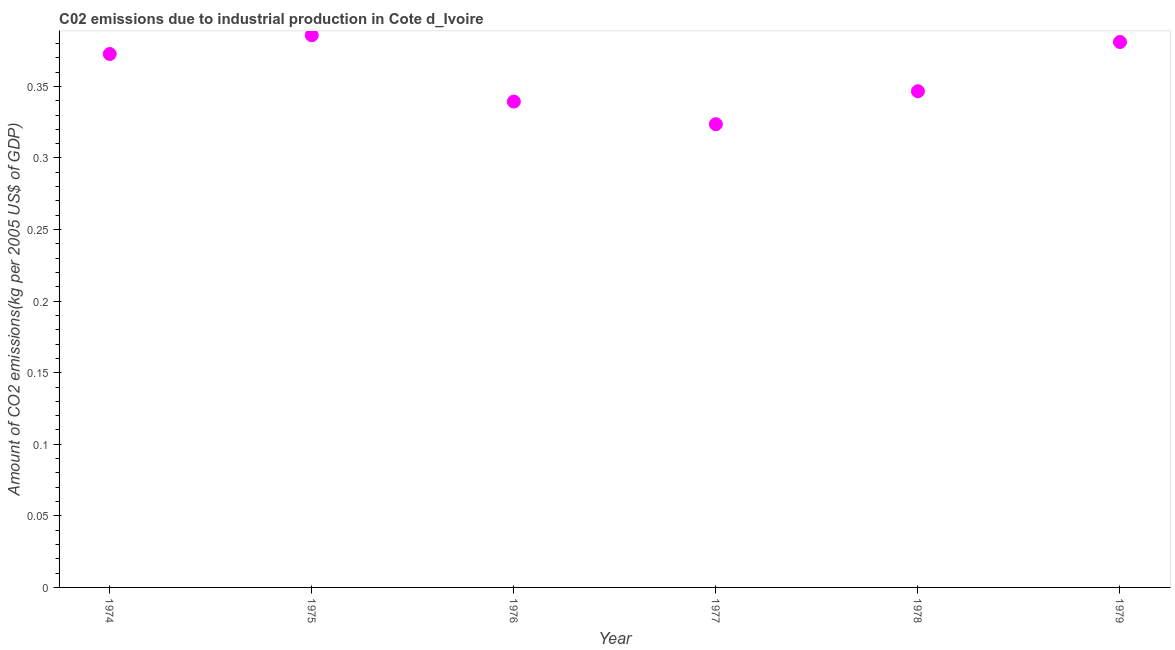What is the amount of co2 emissions in 1979?
Provide a succinct answer. 0.38. Across all years, what is the maximum amount of co2 emissions?
Keep it short and to the point. 0.39. Across all years, what is the minimum amount of co2 emissions?
Your answer should be compact. 0.32. In which year was the amount of co2 emissions maximum?
Give a very brief answer. 1975. What is the sum of the amount of co2 emissions?
Ensure brevity in your answer.  2.15. What is the difference between the amount of co2 emissions in 1976 and 1979?
Ensure brevity in your answer.  -0.04. What is the average amount of co2 emissions per year?
Offer a very short reply. 0.36. What is the median amount of co2 emissions?
Provide a short and direct response. 0.36. In how many years, is the amount of co2 emissions greater than 0.25 kg per 2005 US$ of GDP?
Offer a terse response. 6. What is the ratio of the amount of co2 emissions in 1978 to that in 1979?
Provide a succinct answer. 0.91. Is the amount of co2 emissions in 1976 less than that in 1978?
Provide a succinct answer. Yes. What is the difference between the highest and the second highest amount of co2 emissions?
Make the answer very short. 0. What is the difference between the highest and the lowest amount of co2 emissions?
Your response must be concise. 0.06. Does the amount of co2 emissions monotonically increase over the years?
Your answer should be compact. No. How many years are there in the graph?
Offer a terse response. 6. Are the values on the major ticks of Y-axis written in scientific E-notation?
Keep it short and to the point. No. Does the graph contain any zero values?
Provide a succinct answer. No. Does the graph contain grids?
Provide a succinct answer. No. What is the title of the graph?
Give a very brief answer. C02 emissions due to industrial production in Cote d_Ivoire. What is the label or title of the Y-axis?
Offer a terse response. Amount of CO2 emissions(kg per 2005 US$ of GDP). What is the Amount of CO2 emissions(kg per 2005 US$ of GDP) in 1974?
Offer a very short reply. 0.37. What is the Amount of CO2 emissions(kg per 2005 US$ of GDP) in 1975?
Offer a terse response. 0.39. What is the Amount of CO2 emissions(kg per 2005 US$ of GDP) in 1976?
Your answer should be very brief. 0.34. What is the Amount of CO2 emissions(kg per 2005 US$ of GDP) in 1977?
Your response must be concise. 0.32. What is the Amount of CO2 emissions(kg per 2005 US$ of GDP) in 1978?
Keep it short and to the point. 0.35. What is the Amount of CO2 emissions(kg per 2005 US$ of GDP) in 1979?
Provide a short and direct response. 0.38. What is the difference between the Amount of CO2 emissions(kg per 2005 US$ of GDP) in 1974 and 1975?
Your response must be concise. -0.01. What is the difference between the Amount of CO2 emissions(kg per 2005 US$ of GDP) in 1974 and 1976?
Make the answer very short. 0.03. What is the difference between the Amount of CO2 emissions(kg per 2005 US$ of GDP) in 1974 and 1977?
Ensure brevity in your answer.  0.05. What is the difference between the Amount of CO2 emissions(kg per 2005 US$ of GDP) in 1974 and 1978?
Give a very brief answer. 0.03. What is the difference between the Amount of CO2 emissions(kg per 2005 US$ of GDP) in 1974 and 1979?
Offer a terse response. -0.01. What is the difference between the Amount of CO2 emissions(kg per 2005 US$ of GDP) in 1975 and 1976?
Your response must be concise. 0.05. What is the difference between the Amount of CO2 emissions(kg per 2005 US$ of GDP) in 1975 and 1977?
Your response must be concise. 0.06. What is the difference between the Amount of CO2 emissions(kg per 2005 US$ of GDP) in 1975 and 1978?
Your answer should be very brief. 0.04. What is the difference between the Amount of CO2 emissions(kg per 2005 US$ of GDP) in 1975 and 1979?
Provide a succinct answer. 0. What is the difference between the Amount of CO2 emissions(kg per 2005 US$ of GDP) in 1976 and 1977?
Your response must be concise. 0.02. What is the difference between the Amount of CO2 emissions(kg per 2005 US$ of GDP) in 1976 and 1978?
Provide a succinct answer. -0.01. What is the difference between the Amount of CO2 emissions(kg per 2005 US$ of GDP) in 1976 and 1979?
Make the answer very short. -0.04. What is the difference between the Amount of CO2 emissions(kg per 2005 US$ of GDP) in 1977 and 1978?
Offer a very short reply. -0.02. What is the difference between the Amount of CO2 emissions(kg per 2005 US$ of GDP) in 1977 and 1979?
Your response must be concise. -0.06. What is the difference between the Amount of CO2 emissions(kg per 2005 US$ of GDP) in 1978 and 1979?
Your response must be concise. -0.03. What is the ratio of the Amount of CO2 emissions(kg per 2005 US$ of GDP) in 1974 to that in 1976?
Make the answer very short. 1.1. What is the ratio of the Amount of CO2 emissions(kg per 2005 US$ of GDP) in 1974 to that in 1977?
Provide a short and direct response. 1.15. What is the ratio of the Amount of CO2 emissions(kg per 2005 US$ of GDP) in 1974 to that in 1978?
Give a very brief answer. 1.07. What is the ratio of the Amount of CO2 emissions(kg per 2005 US$ of GDP) in 1974 to that in 1979?
Offer a terse response. 0.98. What is the ratio of the Amount of CO2 emissions(kg per 2005 US$ of GDP) in 1975 to that in 1976?
Make the answer very short. 1.14. What is the ratio of the Amount of CO2 emissions(kg per 2005 US$ of GDP) in 1975 to that in 1977?
Ensure brevity in your answer.  1.19. What is the ratio of the Amount of CO2 emissions(kg per 2005 US$ of GDP) in 1975 to that in 1978?
Provide a short and direct response. 1.11. What is the ratio of the Amount of CO2 emissions(kg per 2005 US$ of GDP) in 1976 to that in 1977?
Your answer should be very brief. 1.05. What is the ratio of the Amount of CO2 emissions(kg per 2005 US$ of GDP) in 1976 to that in 1978?
Give a very brief answer. 0.98. What is the ratio of the Amount of CO2 emissions(kg per 2005 US$ of GDP) in 1976 to that in 1979?
Your response must be concise. 0.89. What is the ratio of the Amount of CO2 emissions(kg per 2005 US$ of GDP) in 1977 to that in 1978?
Ensure brevity in your answer.  0.93. What is the ratio of the Amount of CO2 emissions(kg per 2005 US$ of GDP) in 1977 to that in 1979?
Ensure brevity in your answer.  0.85. What is the ratio of the Amount of CO2 emissions(kg per 2005 US$ of GDP) in 1978 to that in 1979?
Your response must be concise. 0.91. 